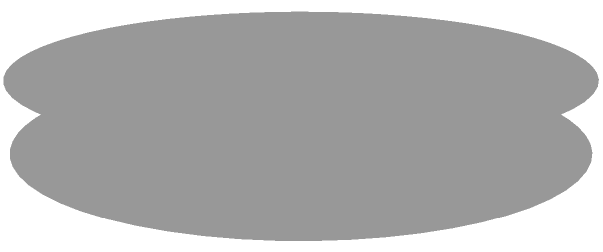You're designing a new barbell plate for your powerlifting gym and want to calculate its volume. The plate has an outer radius $R = 10$ inches, an inner radius $r = 2$ inches, and a thickness $h = 1$ inch. Using the method of cylindrical shells, set up the integral to find the volume of the plate. What is the final volume in cubic inches? Let's approach this step-by-step:

1) The method of cylindrical shells involves integrating the volume of thin cylindrical shells from the inner radius to the outer radius.

2) For each cylindrical shell:
   - The radius is x
   - The height is h (constant)
   - The thickness is dx

3) The volume of each shell is: $dV = 2\pi x h dx$

4) We integrate this from the inner radius (r) to the outer radius (R):

   $$V = \int_r^R 2\pi x h dx$$

5) Substituting the given values:

   $$V = \int_2^{10} 2\pi x (1) dx$$

6) Simplifying:

   $$V = 2\pi \int_2^{10} x dx$$

7) Integrating:

   $$V = 2\pi [\frac{x^2}{2}]_2^{10}$$

8) Evaluating:

   $$V = 2\pi [\frac{10^2}{2} - \frac{2^2}{2}]$$
   $$V = 2\pi [50 - 2]$$
   $$V = 2\pi (48)$$
   $$V = 96\pi$$

9) Calculator: $96\pi \approx 301.59$ cubic inches
Answer: $96\pi$ cubic inches (approximately 301.59 cubic inches) 